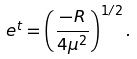Convert formula to latex. <formula><loc_0><loc_0><loc_500><loc_500>e ^ { t } = \left ( \frac { - R } { 4 \mu ^ { 2 } } \right ) ^ { 1 / 2 } .</formula> 